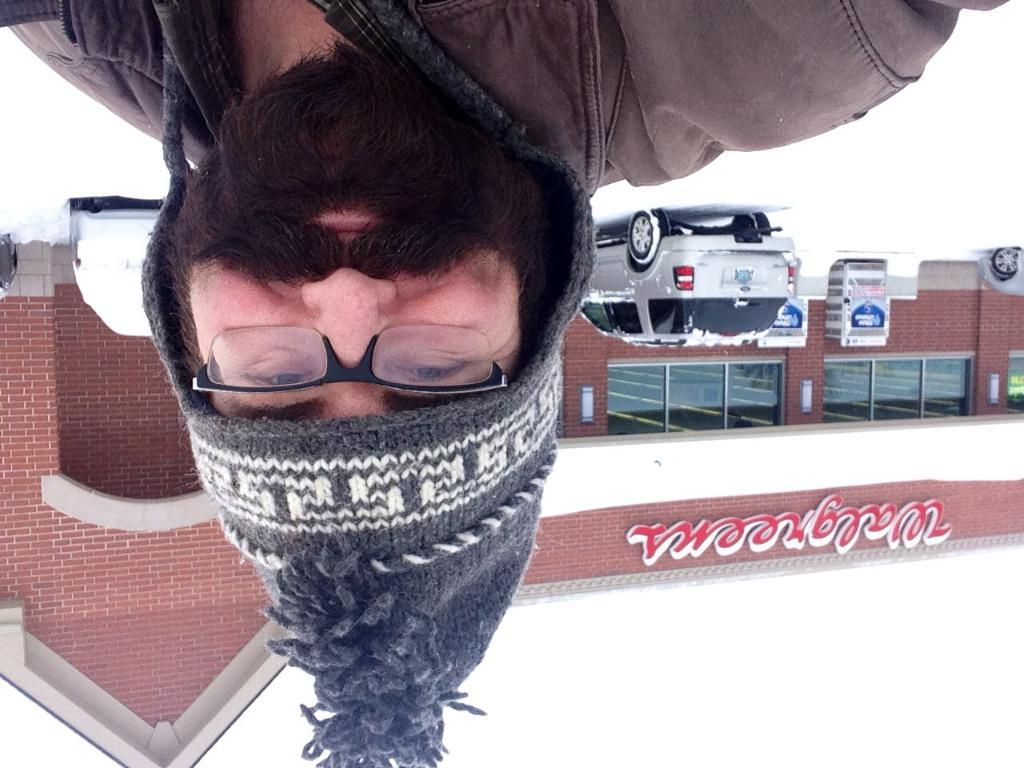Who or what is the main subject in the image? There is a person in the image. What can be seen in the distance behind the person? There are vehicles and at least one building visible in the background of the image. Can you describe any other objects or features in the background? Yes, there are other objects visible in the background of the image. What is the price of the vegetable being sold by the person in the image? There is no vegetable being sold by the person in the image, nor is there any indication of a price. 